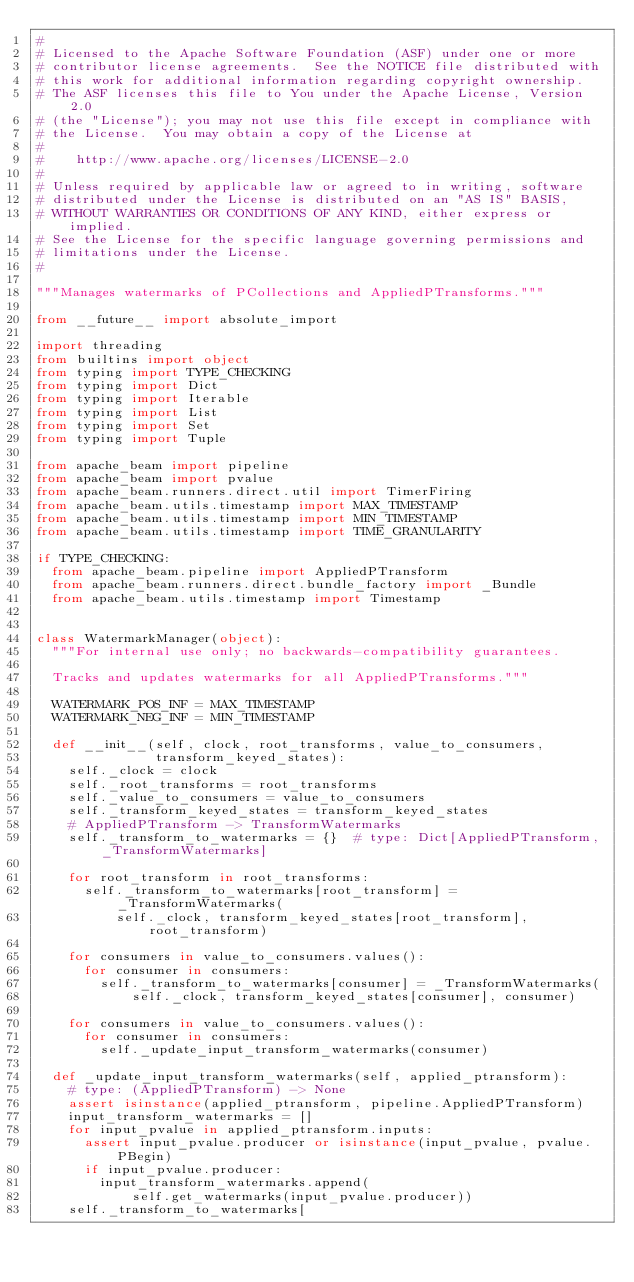Convert code to text. <code><loc_0><loc_0><loc_500><loc_500><_Python_>#
# Licensed to the Apache Software Foundation (ASF) under one or more
# contributor license agreements.  See the NOTICE file distributed with
# this work for additional information regarding copyright ownership.
# The ASF licenses this file to You under the Apache License, Version 2.0
# (the "License"); you may not use this file except in compliance with
# the License.  You may obtain a copy of the License at
#
#    http://www.apache.org/licenses/LICENSE-2.0
#
# Unless required by applicable law or agreed to in writing, software
# distributed under the License is distributed on an "AS IS" BASIS,
# WITHOUT WARRANTIES OR CONDITIONS OF ANY KIND, either express or implied.
# See the License for the specific language governing permissions and
# limitations under the License.
#

"""Manages watermarks of PCollections and AppliedPTransforms."""

from __future__ import absolute_import

import threading
from builtins import object
from typing import TYPE_CHECKING
from typing import Dict
from typing import Iterable
from typing import List
from typing import Set
from typing import Tuple

from apache_beam import pipeline
from apache_beam import pvalue
from apache_beam.runners.direct.util import TimerFiring
from apache_beam.utils.timestamp import MAX_TIMESTAMP
from apache_beam.utils.timestamp import MIN_TIMESTAMP
from apache_beam.utils.timestamp import TIME_GRANULARITY

if TYPE_CHECKING:
  from apache_beam.pipeline import AppliedPTransform
  from apache_beam.runners.direct.bundle_factory import _Bundle
  from apache_beam.utils.timestamp import Timestamp


class WatermarkManager(object):
  """For internal use only; no backwards-compatibility guarantees.

  Tracks and updates watermarks for all AppliedPTransforms."""

  WATERMARK_POS_INF = MAX_TIMESTAMP
  WATERMARK_NEG_INF = MIN_TIMESTAMP

  def __init__(self, clock, root_transforms, value_to_consumers,
               transform_keyed_states):
    self._clock = clock
    self._root_transforms = root_transforms
    self._value_to_consumers = value_to_consumers
    self._transform_keyed_states = transform_keyed_states
    # AppliedPTransform -> TransformWatermarks
    self._transform_to_watermarks = {}  # type: Dict[AppliedPTransform, _TransformWatermarks]

    for root_transform in root_transforms:
      self._transform_to_watermarks[root_transform] = _TransformWatermarks(
          self._clock, transform_keyed_states[root_transform], root_transform)

    for consumers in value_to_consumers.values():
      for consumer in consumers:
        self._transform_to_watermarks[consumer] = _TransformWatermarks(
            self._clock, transform_keyed_states[consumer], consumer)

    for consumers in value_to_consumers.values():
      for consumer in consumers:
        self._update_input_transform_watermarks(consumer)

  def _update_input_transform_watermarks(self, applied_ptransform):
    # type: (AppliedPTransform) -> None
    assert isinstance(applied_ptransform, pipeline.AppliedPTransform)
    input_transform_watermarks = []
    for input_pvalue in applied_ptransform.inputs:
      assert input_pvalue.producer or isinstance(input_pvalue, pvalue.PBegin)
      if input_pvalue.producer:
        input_transform_watermarks.append(
            self.get_watermarks(input_pvalue.producer))
    self._transform_to_watermarks[</code> 